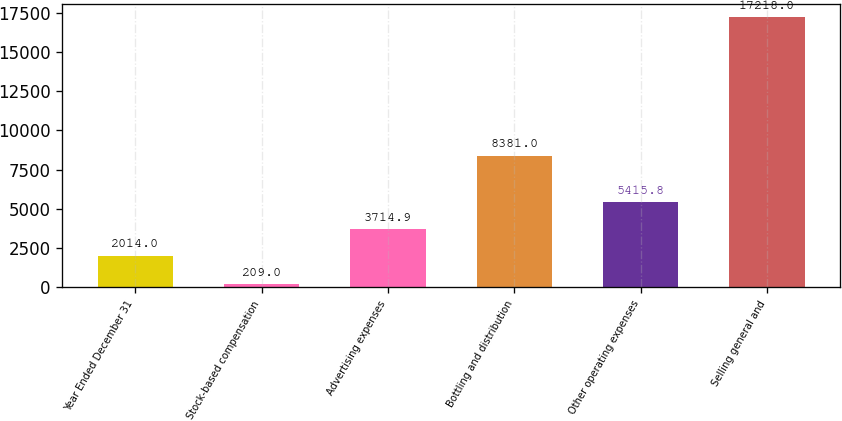<chart> <loc_0><loc_0><loc_500><loc_500><bar_chart><fcel>Year Ended December 31<fcel>Stock-based compensation<fcel>Advertising expenses<fcel>Bottling and distribution<fcel>Other operating expenses<fcel>Selling general and<nl><fcel>2014<fcel>209<fcel>3714.9<fcel>8381<fcel>5415.8<fcel>17218<nl></chart> 